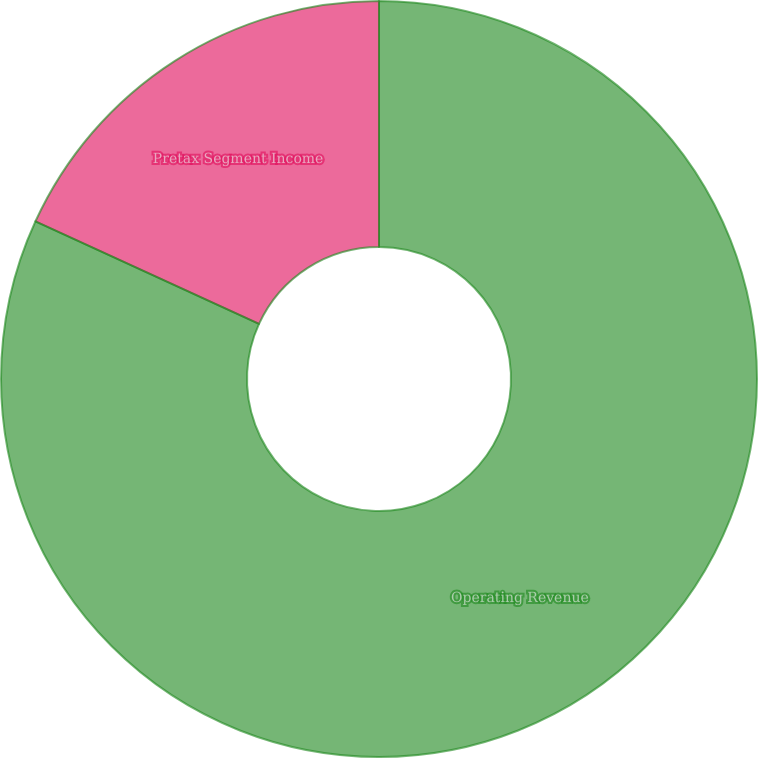<chart> <loc_0><loc_0><loc_500><loc_500><pie_chart><fcel>Operating Revenue<fcel>Pretax Segment Income<nl><fcel>81.85%<fcel>18.15%<nl></chart> 